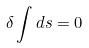<formula> <loc_0><loc_0><loc_500><loc_500>\delta \int d s = 0</formula> 